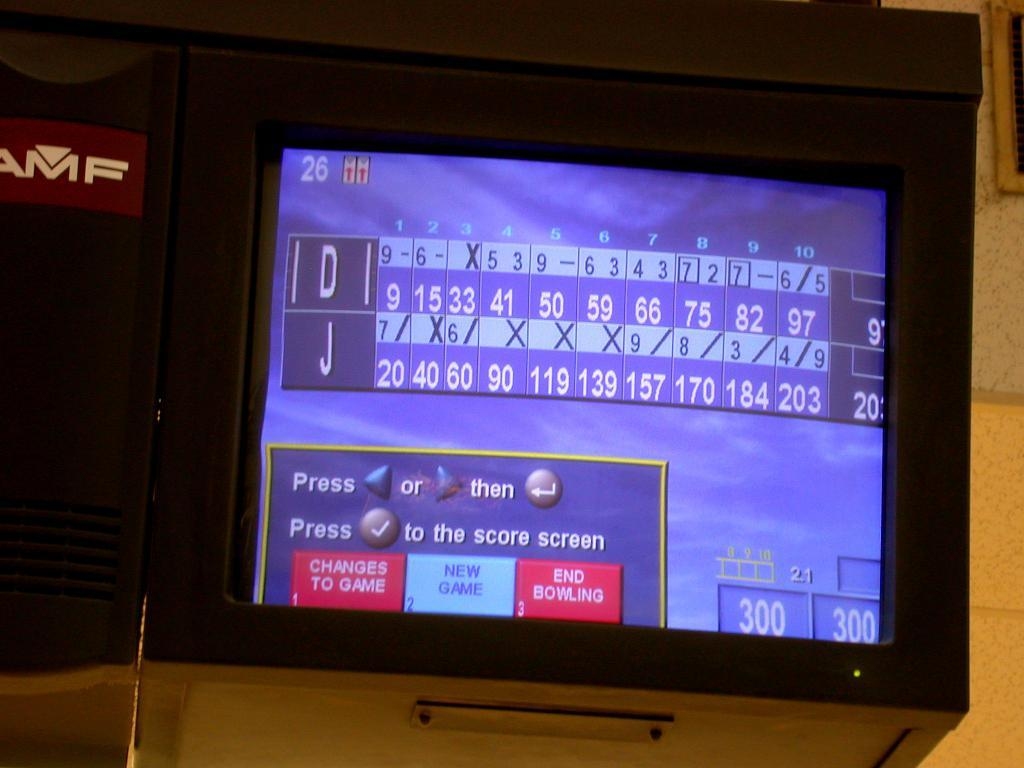Provide a one-sentence caption for the provided image. The score of a bowling game has options, such as "changes to game" and "new game.". 